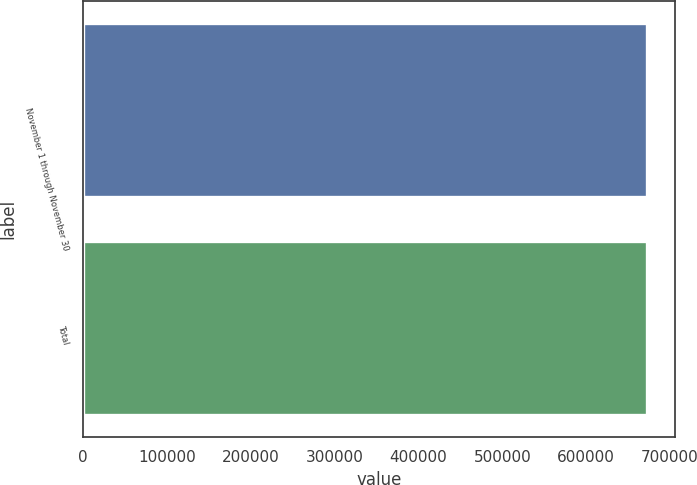Convert chart to OTSL. <chart><loc_0><loc_0><loc_500><loc_500><bar_chart><fcel>November 1 through November 30<fcel>Total<nl><fcel>672500<fcel>672500<nl></chart> 